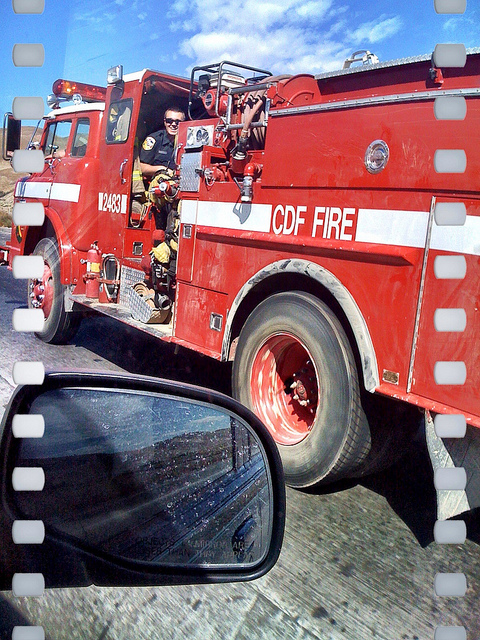How many brown cows are there? Upon reviewing the image, there are no brown cows present. The image features a red fire truck with firefighters on board, reflecting the theme of emergency services rather than farm or rural settings. 